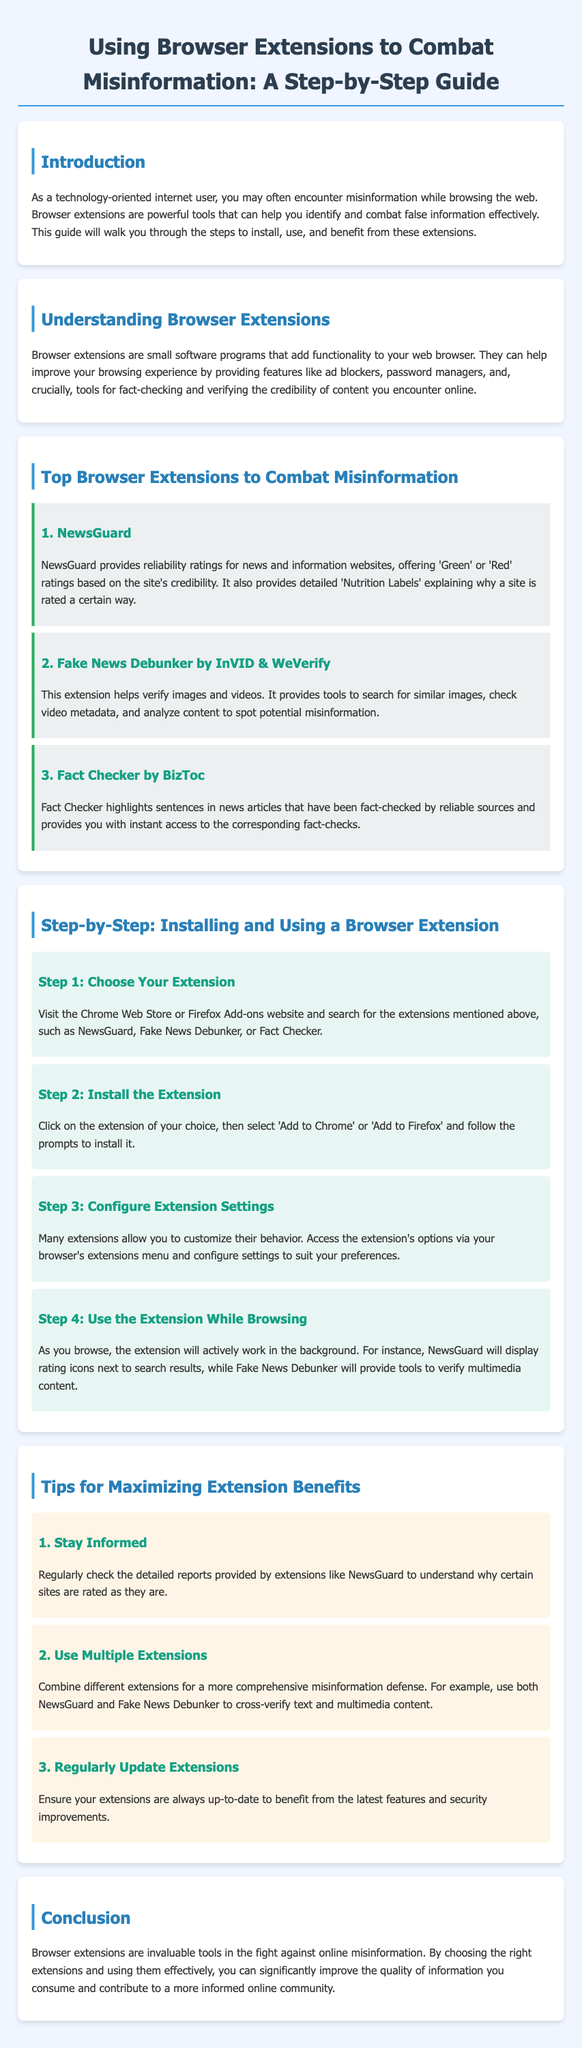What is the title of the guide? The title of the guide is stated clearly at the top of the document.
Answer: Using Browser Extensions to Combat Misinformation: A Step-by-Step Guide How many browser extensions are listed to combat misinformation? The document provides a specific number of extensions in the section about top browser extensions.
Answer: 3 What is the first step to install a browser extension? The document outlines the installation process starting with the first step.
Answer: Choose Your Extension Which extension provides reliability ratings for news websites? The document specifies which extension offers reliability ratings for news and information websites.
Answer: NewsGuard What should you combine for a more comprehensive misinformation defense? The guide suggests combining different extensions for improved defense against misinformation.
Answer: Multiple Extensions What kind of reports should you regularly check to stay informed? The document advises on what type of reports to review for more information about site ratings.
Answer: Detailed reports Which color represents reliable sites in NewsGuard ratings? The document mentions the color coding used in the rating system by NewsGuard.
Answer: Green What is advised to ensure you benefit from the latest features? The importance of keeping extensions current is highlighted in the tips section of the document.
Answer: Regularly Update Extensions 